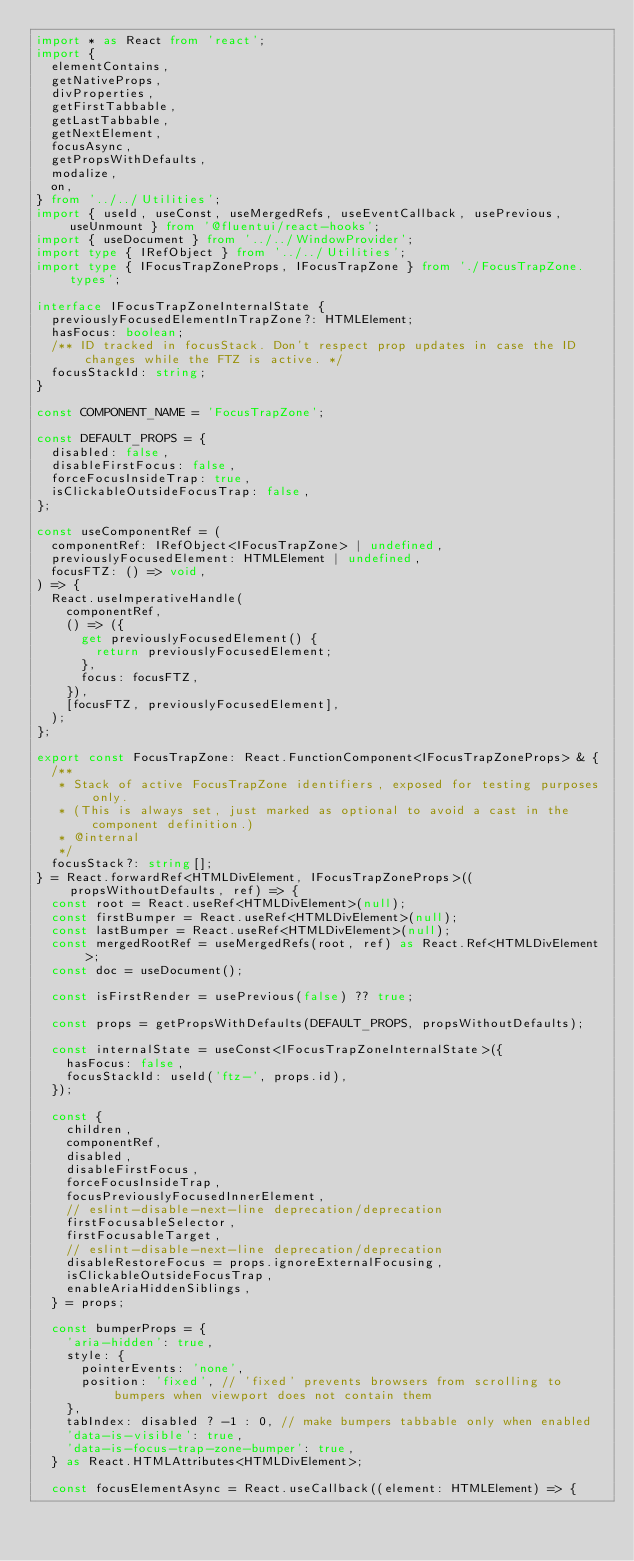Convert code to text. <code><loc_0><loc_0><loc_500><loc_500><_TypeScript_>import * as React from 'react';
import {
  elementContains,
  getNativeProps,
  divProperties,
  getFirstTabbable,
  getLastTabbable,
  getNextElement,
  focusAsync,
  getPropsWithDefaults,
  modalize,
  on,
} from '../../Utilities';
import { useId, useConst, useMergedRefs, useEventCallback, usePrevious, useUnmount } from '@fluentui/react-hooks';
import { useDocument } from '../../WindowProvider';
import type { IRefObject } from '../../Utilities';
import type { IFocusTrapZoneProps, IFocusTrapZone } from './FocusTrapZone.types';

interface IFocusTrapZoneInternalState {
  previouslyFocusedElementInTrapZone?: HTMLElement;
  hasFocus: boolean;
  /** ID tracked in focusStack. Don't respect prop updates in case the ID changes while the FTZ is active. */
  focusStackId: string;
}

const COMPONENT_NAME = 'FocusTrapZone';

const DEFAULT_PROPS = {
  disabled: false,
  disableFirstFocus: false,
  forceFocusInsideTrap: true,
  isClickableOutsideFocusTrap: false,
};

const useComponentRef = (
  componentRef: IRefObject<IFocusTrapZone> | undefined,
  previouslyFocusedElement: HTMLElement | undefined,
  focusFTZ: () => void,
) => {
  React.useImperativeHandle(
    componentRef,
    () => ({
      get previouslyFocusedElement() {
        return previouslyFocusedElement;
      },
      focus: focusFTZ,
    }),
    [focusFTZ, previouslyFocusedElement],
  );
};

export const FocusTrapZone: React.FunctionComponent<IFocusTrapZoneProps> & {
  /**
   * Stack of active FocusTrapZone identifiers, exposed for testing purposes only.
   * (This is always set, just marked as optional to avoid a cast in the component definition.)
   * @internal
   */
  focusStack?: string[];
} = React.forwardRef<HTMLDivElement, IFocusTrapZoneProps>((propsWithoutDefaults, ref) => {
  const root = React.useRef<HTMLDivElement>(null);
  const firstBumper = React.useRef<HTMLDivElement>(null);
  const lastBumper = React.useRef<HTMLDivElement>(null);
  const mergedRootRef = useMergedRefs(root, ref) as React.Ref<HTMLDivElement>;
  const doc = useDocument();

  const isFirstRender = usePrevious(false) ?? true;

  const props = getPropsWithDefaults(DEFAULT_PROPS, propsWithoutDefaults);

  const internalState = useConst<IFocusTrapZoneInternalState>({
    hasFocus: false,
    focusStackId: useId('ftz-', props.id),
  });

  const {
    children,
    componentRef,
    disabled,
    disableFirstFocus,
    forceFocusInsideTrap,
    focusPreviouslyFocusedInnerElement,
    // eslint-disable-next-line deprecation/deprecation
    firstFocusableSelector,
    firstFocusableTarget,
    // eslint-disable-next-line deprecation/deprecation
    disableRestoreFocus = props.ignoreExternalFocusing,
    isClickableOutsideFocusTrap,
    enableAriaHiddenSiblings,
  } = props;

  const bumperProps = {
    'aria-hidden': true,
    style: {
      pointerEvents: 'none',
      position: 'fixed', // 'fixed' prevents browsers from scrolling to bumpers when viewport does not contain them
    },
    tabIndex: disabled ? -1 : 0, // make bumpers tabbable only when enabled
    'data-is-visible': true,
    'data-is-focus-trap-zone-bumper': true,
  } as React.HTMLAttributes<HTMLDivElement>;

  const focusElementAsync = React.useCallback((element: HTMLElement) => {</code> 